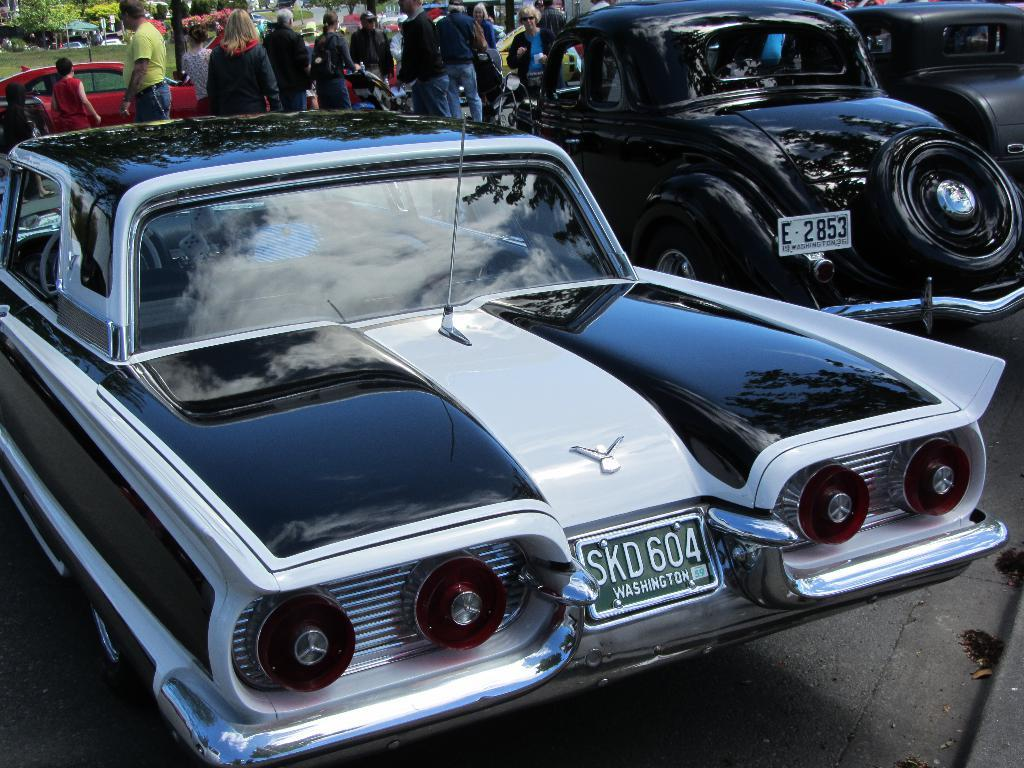What can be seen on the road in the image? There are vehicles on the road in the image. What else is present in the image besides the vehicles? There is a group of people standing in the image. What type of natural environment is visible in the image? There is grass and trees visible in the image. What type of metal is being distributed by the group of people in the image? There is no metal being distributed by the group of people in the image. What type of work are the people in the image engaged in? The image does not provide information about the people's work or occupation. 